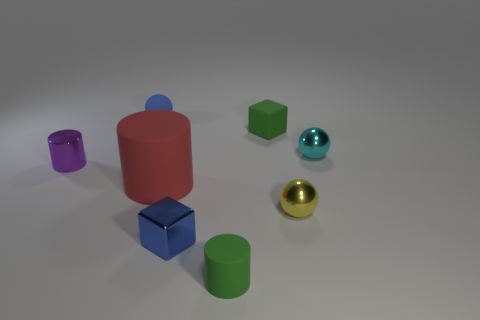Are there any other things that have the same size as the red cylinder?
Offer a very short reply. No. What number of blue rubber objects are on the left side of the ball on the left side of the metallic ball that is in front of the metal cylinder?
Ensure brevity in your answer.  0. What color is the rubber cylinder that is in front of the shiny block?
Offer a very short reply. Green. What shape is the small green thing to the right of the rubber cylinder that is on the right side of the tiny blue metal object?
Give a very brief answer. Cube. Is the metallic cube the same color as the rubber cube?
Make the answer very short. No. How many cubes are either tiny metal things or tiny cyan objects?
Your answer should be compact. 1. The tiny object that is both on the right side of the rubber block and in front of the cyan ball is made of what material?
Offer a very short reply. Metal. There is a tiny matte sphere; how many objects are on the left side of it?
Provide a short and direct response. 1. Is the material of the tiny cylinder on the right side of the purple thing the same as the cube that is in front of the large rubber cylinder?
Offer a very short reply. No. How many objects are rubber cylinders behind the blue cube or tiny blue cubes?
Your response must be concise. 2. 